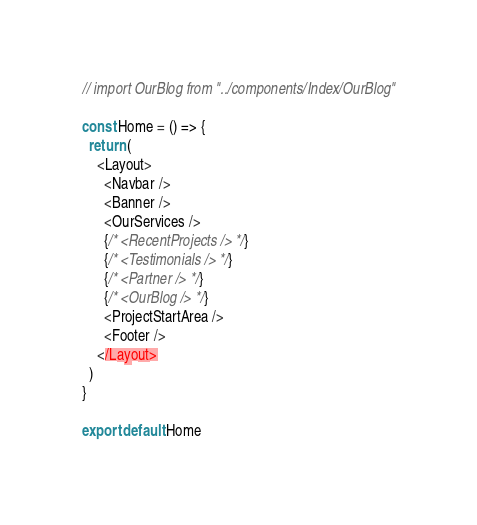<code> <loc_0><loc_0><loc_500><loc_500><_JavaScript_>// import OurBlog from "../components/Index/OurBlog"

const Home = () => {
  return (
    <Layout>
      <Navbar />
      <Banner />
      <OurServices />
      {/* <RecentProjects /> */}
      {/* <Testimonials /> */}
      {/* <Partner /> */}
      {/* <OurBlog /> */}
      <ProjectStartArea />
      <Footer />
    </Layout>
  )
}

export default Home</code> 